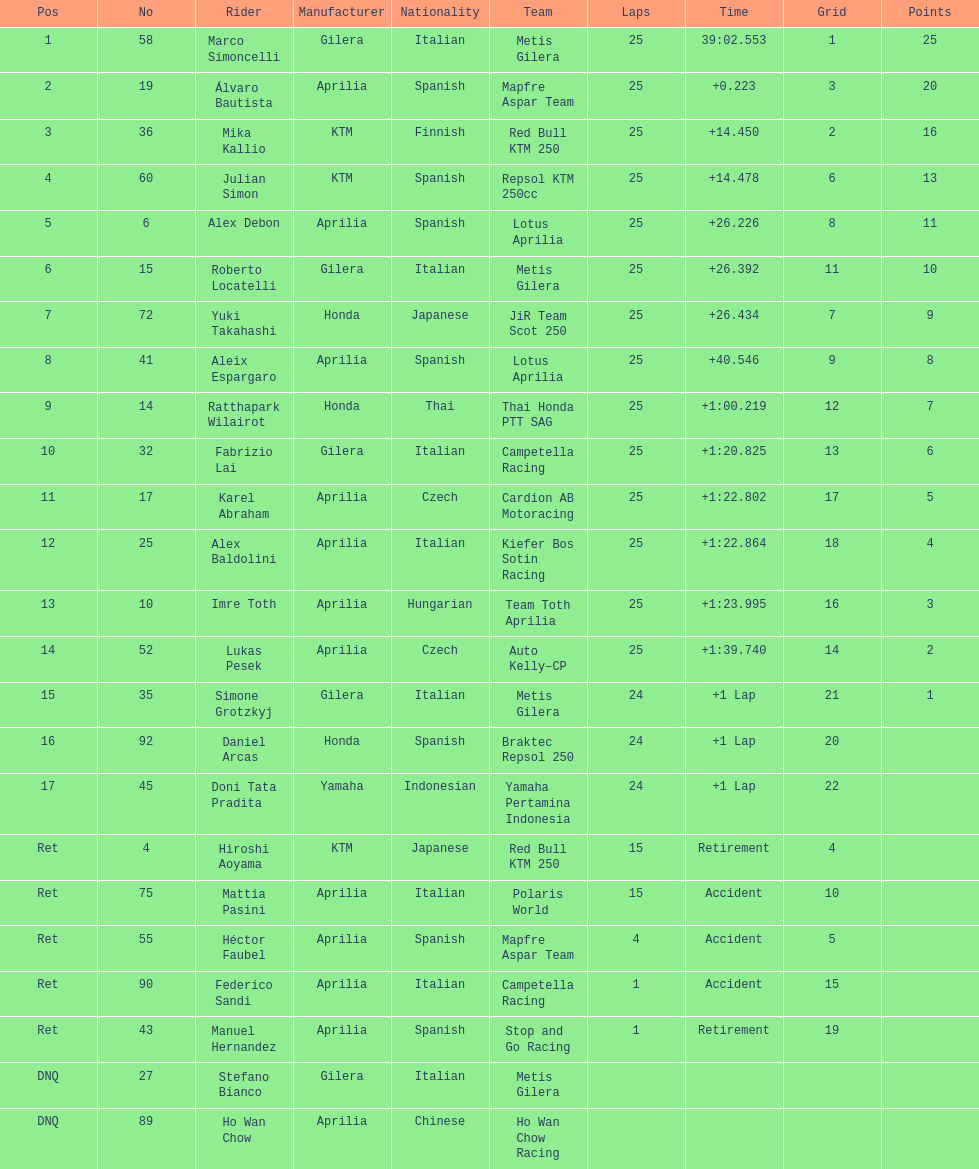What is the overall count of riders? 24. 